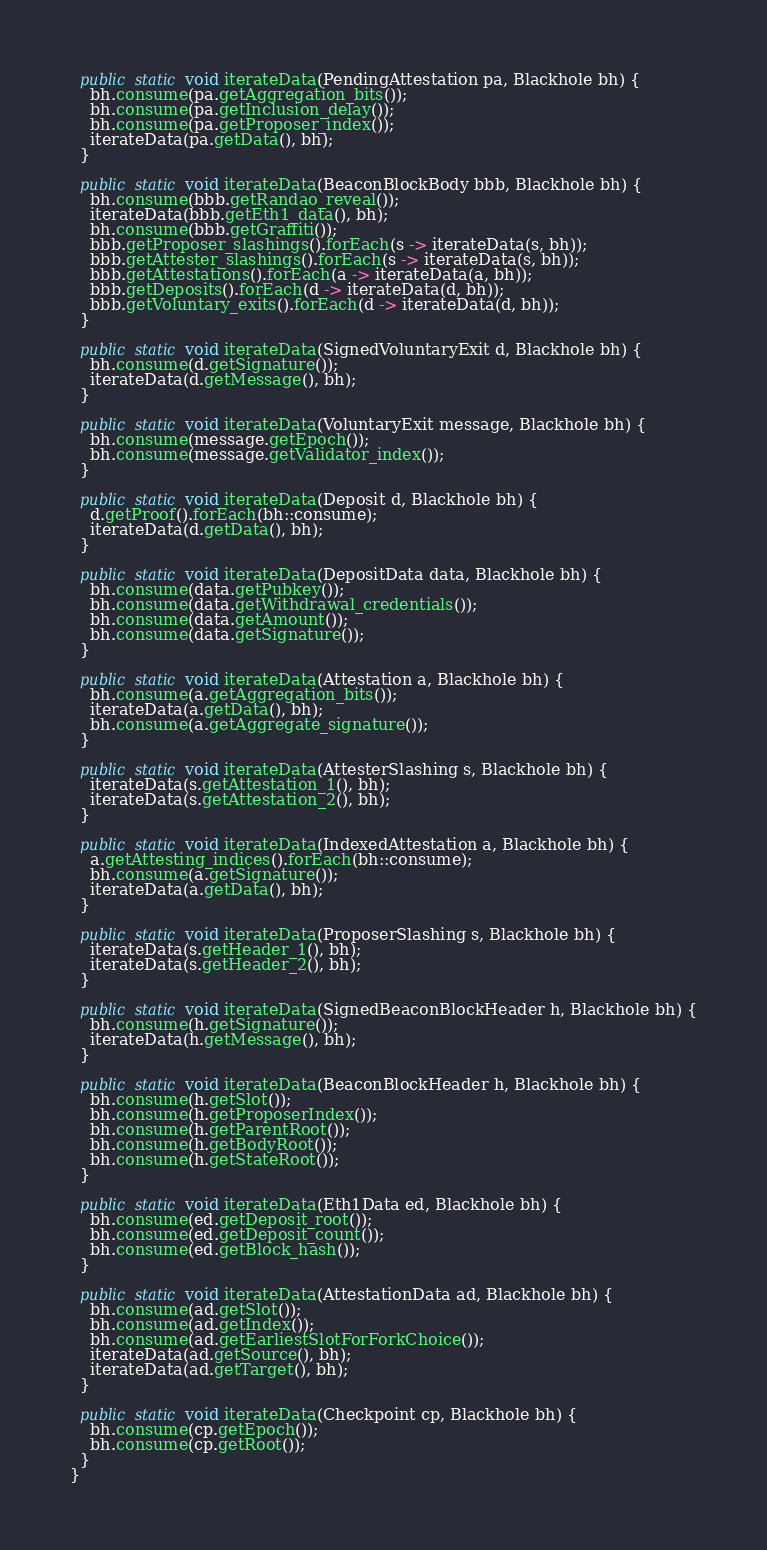Convert code to text. <code><loc_0><loc_0><loc_500><loc_500><_Java_>
  public static void iterateData(PendingAttestation pa, Blackhole bh) {
    bh.consume(pa.getAggregation_bits());
    bh.consume(pa.getInclusion_delay());
    bh.consume(pa.getProposer_index());
    iterateData(pa.getData(), bh);
  }

  public static void iterateData(BeaconBlockBody bbb, Blackhole bh) {
    bh.consume(bbb.getRandao_reveal());
    iterateData(bbb.getEth1_data(), bh);
    bh.consume(bbb.getGraffiti());
    bbb.getProposer_slashings().forEach(s -> iterateData(s, bh));
    bbb.getAttester_slashings().forEach(s -> iterateData(s, bh));
    bbb.getAttestations().forEach(a -> iterateData(a, bh));
    bbb.getDeposits().forEach(d -> iterateData(d, bh));
    bbb.getVoluntary_exits().forEach(d -> iterateData(d, bh));
  }

  public static void iterateData(SignedVoluntaryExit d, Blackhole bh) {
    bh.consume(d.getSignature());
    iterateData(d.getMessage(), bh);
  }

  public static void iterateData(VoluntaryExit message, Blackhole bh) {
    bh.consume(message.getEpoch());
    bh.consume(message.getValidator_index());
  }

  public static void iterateData(Deposit d, Blackhole bh) {
    d.getProof().forEach(bh::consume);
    iterateData(d.getData(), bh);
  }

  public static void iterateData(DepositData data, Blackhole bh) {
    bh.consume(data.getPubkey());
    bh.consume(data.getWithdrawal_credentials());
    bh.consume(data.getAmount());
    bh.consume(data.getSignature());
  }

  public static void iterateData(Attestation a, Blackhole bh) {
    bh.consume(a.getAggregation_bits());
    iterateData(a.getData(), bh);
    bh.consume(a.getAggregate_signature());
  }

  public static void iterateData(AttesterSlashing s, Blackhole bh) {
    iterateData(s.getAttestation_1(), bh);
    iterateData(s.getAttestation_2(), bh);
  }

  public static void iterateData(IndexedAttestation a, Blackhole bh) {
    a.getAttesting_indices().forEach(bh::consume);
    bh.consume(a.getSignature());
    iterateData(a.getData(), bh);
  }

  public static void iterateData(ProposerSlashing s, Blackhole bh) {
    iterateData(s.getHeader_1(), bh);
    iterateData(s.getHeader_2(), bh);
  }

  public static void iterateData(SignedBeaconBlockHeader h, Blackhole bh) {
    bh.consume(h.getSignature());
    iterateData(h.getMessage(), bh);
  }

  public static void iterateData(BeaconBlockHeader h, Blackhole bh) {
    bh.consume(h.getSlot());
    bh.consume(h.getProposerIndex());
    bh.consume(h.getParentRoot());
    bh.consume(h.getBodyRoot());
    bh.consume(h.getStateRoot());
  }

  public static void iterateData(Eth1Data ed, Blackhole bh) {
    bh.consume(ed.getDeposit_root());
    bh.consume(ed.getDeposit_count());
    bh.consume(ed.getBlock_hash());
  }

  public static void iterateData(AttestationData ad, Blackhole bh) {
    bh.consume(ad.getSlot());
    bh.consume(ad.getIndex());
    bh.consume(ad.getEarliestSlotForForkChoice());
    iterateData(ad.getSource(), bh);
    iterateData(ad.getTarget(), bh);
  }

  public static void iterateData(Checkpoint cp, Blackhole bh) {
    bh.consume(cp.getEpoch());
    bh.consume(cp.getRoot());
  }
}
</code> 